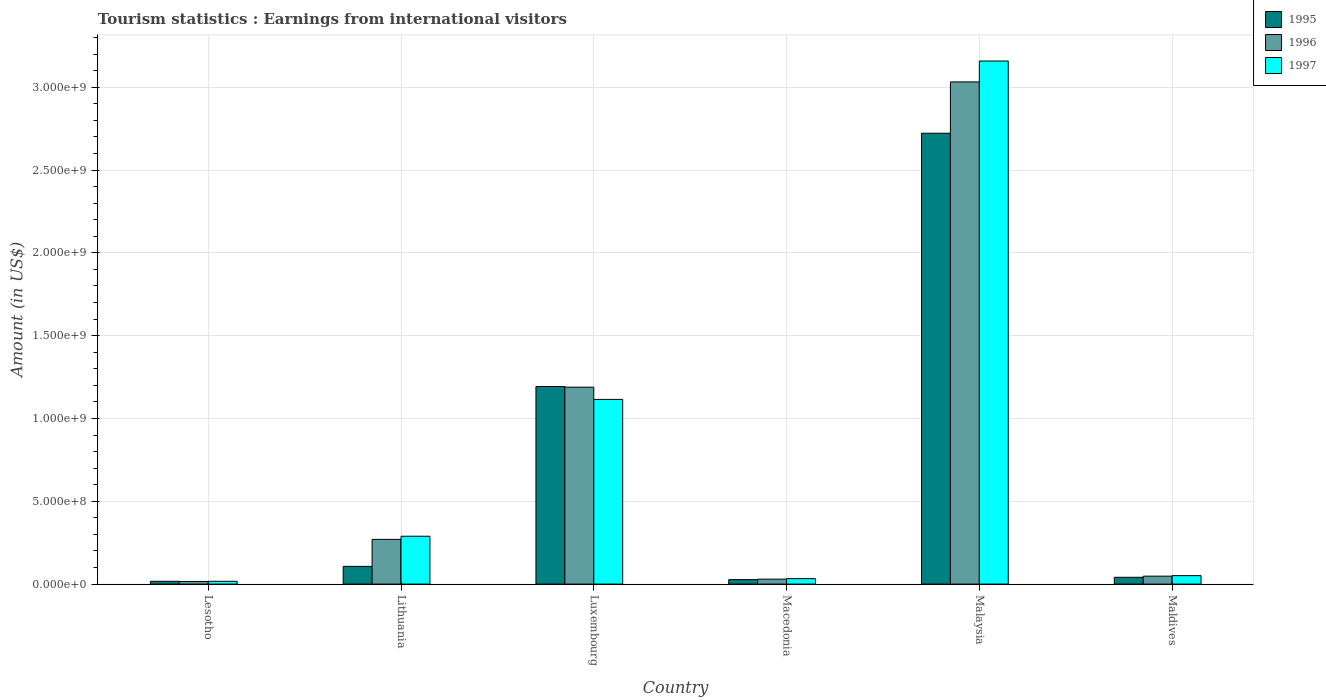How many different coloured bars are there?
Give a very brief answer. 3. Are the number of bars on each tick of the X-axis equal?
Ensure brevity in your answer.  Yes. How many bars are there on the 1st tick from the left?
Offer a terse response. 3. What is the label of the 5th group of bars from the left?
Offer a very short reply. Malaysia. In how many cases, is the number of bars for a given country not equal to the number of legend labels?
Your response must be concise. 0. What is the earnings from international visitors in 1996 in Malaysia?
Offer a terse response. 3.03e+09. Across all countries, what is the maximum earnings from international visitors in 1995?
Offer a terse response. 2.72e+09. Across all countries, what is the minimum earnings from international visitors in 1997?
Offer a very short reply. 1.70e+07. In which country was the earnings from international visitors in 1997 maximum?
Give a very brief answer. Malaysia. In which country was the earnings from international visitors in 1996 minimum?
Offer a terse response. Lesotho. What is the total earnings from international visitors in 1995 in the graph?
Give a very brief answer. 4.11e+09. What is the difference between the earnings from international visitors in 1997 in Lithuania and that in Malaysia?
Ensure brevity in your answer.  -2.87e+09. What is the difference between the earnings from international visitors in 1995 in Malaysia and the earnings from international visitors in 1996 in Luxembourg?
Provide a succinct answer. 1.53e+09. What is the average earnings from international visitors in 1997 per country?
Provide a succinct answer. 7.77e+08. What is the difference between the earnings from international visitors of/in 1995 and earnings from international visitors of/in 1997 in Macedonia?
Keep it short and to the point. -6.00e+06. In how many countries, is the earnings from international visitors in 1997 greater than 2800000000 US$?
Keep it short and to the point. 1. What is the ratio of the earnings from international visitors in 1995 in Lesotho to that in Lithuania?
Keep it short and to the point. 0.16. What is the difference between the highest and the second highest earnings from international visitors in 1995?
Provide a succinct answer. 1.53e+09. What is the difference between the highest and the lowest earnings from international visitors in 1996?
Your answer should be very brief. 3.02e+09. What does the 3rd bar from the right in Lesotho represents?
Provide a succinct answer. 1995. Is it the case that in every country, the sum of the earnings from international visitors in 1995 and earnings from international visitors in 1997 is greater than the earnings from international visitors in 1996?
Give a very brief answer. Yes. How many bars are there?
Offer a very short reply. 18. Are all the bars in the graph horizontal?
Give a very brief answer. No. What is the difference between two consecutive major ticks on the Y-axis?
Give a very brief answer. 5.00e+08. Does the graph contain any zero values?
Offer a terse response. No. Does the graph contain grids?
Make the answer very short. Yes. How many legend labels are there?
Give a very brief answer. 3. How are the legend labels stacked?
Make the answer very short. Vertical. What is the title of the graph?
Your answer should be compact. Tourism statistics : Earnings from international visitors. What is the label or title of the X-axis?
Ensure brevity in your answer.  Country. What is the Amount (in US$) in 1995 in Lesotho?
Ensure brevity in your answer.  1.70e+07. What is the Amount (in US$) of 1996 in Lesotho?
Your answer should be very brief. 1.60e+07. What is the Amount (in US$) of 1997 in Lesotho?
Keep it short and to the point. 1.70e+07. What is the Amount (in US$) in 1995 in Lithuania?
Your answer should be very brief. 1.07e+08. What is the Amount (in US$) of 1996 in Lithuania?
Provide a short and direct response. 2.70e+08. What is the Amount (in US$) of 1997 in Lithuania?
Offer a terse response. 2.89e+08. What is the Amount (in US$) in 1995 in Luxembourg?
Offer a very short reply. 1.19e+09. What is the Amount (in US$) of 1996 in Luxembourg?
Give a very brief answer. 1.19e+09. What is the Amount (in US$) in 1997 in Luxembourg?
Give a very brief answer. 1.12e+09. What is the Amount (in US$) of 1995 in Macedonia?
Provide a short and direct response. 2.70e+07. What is the Amount (in US$) of 1996 in Macedonia?
Provide a succinct answer. 3.00e+07. What is the Amount (in US$) of 1997 in Macedonia?
Offer a terse response. 3.30e+07. What is the Amount (in US$) of 1995 in Malaysia?
Your response must be concise. 2.72e+09. What is the Amount (in US$) of 1996 in Malaysia?
Keep it short and to the point. 3.03e+09. What is the Amount (in US$) in 1997 in Malaysia?
Make the answer very short. 3.16e+09. What is the Amount (in US$) of 1995 in Maldives?
Offer a terse response. 4.10e+07. What is the Amount (in US$) in 1996 in Maldives?
Provide a short and direct response. 4.80e+07. What is the Amount (in US$) in 1997 in Maldives?
Give a very brief answer. 5.10e+07. Across all countries, what is the maximum Amount (in US$) of 1995?
Offer a terse response. 2.72e+09. Across all countries, what is the maximum Amount (in US$) of 1996?
Make the answer very short. 3.03e+09. Across all countries, what is the maximum Amount (in US$) in 1997?
Your response must be concise. 3.16e+09. Across all countries, what is the minimum Amount (in US$) in 1995?
Provide a succinct answer. 1.70e+07. Across all countries, what is the minimum Amount (in US$) in 1996?
Keep it short and to the point. 1.60e+07. Across all countries, what is the minimum Amount (in US$) of 1997?
Make the answer very short. 1.70e+07. What is the total Amount (in US$) in 1995 in the graph?
Ensure brevity in your answer.  4.11e+09. What is the total Amount (in US$) in 1996 in the graph?
Your answer should be compact. 4.58e+09. What is the total Amount (in US$) of 1997 in the graph?
Ensure brevity in your answer.  4.66e+09. What is the difference between the Amount (in US$) of 1995 in Lesotho and that in Lithuania?
Your response must be concise. -9.00e+07. What is the difference between the Amount (in US$) of 1996 in Lesotho and that in Lithuania?
Keep it short and to the point. -2.54e+08. What is the difference between the Amount (in US$) in 1997 in Lesotho and that in Lithuania?
Provide a succinct answer. -2.72e+08. What is the difference between the Amount (in US$) of 1995 in Lesotho and that in Luxembourg?
Your answer should be compact. -1.18e+09. What is the difference between the Amount (in US$) in 1996 in Lesotho and that in Luxembourg?
Your response must be concise. -1.17e+09. What is the difference between the Amount (in US$) of 1997 in Lesotho and that in Luxembourg?
Your answer should be compact. -1.10e+09. What is the difference between the Amount (in US$) of 1995 in Lesotho and that in Macedonia?
Provide a succinct answer. -1.00e+07. What is the difference between the Amount (in US$) of 1996 in Lesotho and that in Macedonia?
Your answer should be very brief. -1.40e+07. What is the difference between the Amount (in US$) in 1997 in Lesotho and that in Macedonia?
Provide a succinct answer. -1.60e+07. What is the difference between the Amount (in US$) of 1995 in Lesotho and that in Malaysia?
Your answer should be very brief. -2.70e+09. What is the difference between the Amount (in US$) of 1996 in Lesotho and that in Malaysia?
Your response must be concise. -3.02e+09. What is the difference between the Amount (in US$) in 1997 in Lesotho and that in Malaysia?
Offer a very short reply. -3.14e+09. What is the difference between the Amount (in US$) in 1995 in Lesotho and that in Maldives?
Your response must be concise. -2.40e+07. What is the difference between the Amount (in US$) of 1996 in Lesotho and that in Maldives?
Offer a very short reply. -3.20e+07. What is the difference between the Amount (in US$) in 1997 in Lesotho and that in Maldives?
Offer a very short reply. -3.40e+07. What is the difference between the Amount (in US$) in 1995 in Lithuania and that in Luxembourg?
Your answer should be very brief. -1.09e+09. What is the difference between the Amount (in US$) in 1996 in Lithuania and that in Luxembourg?
Ensure brevity in your answer.  -9.19e+08. What is the difference between the Amount (in US$) of 1997 in Lithuania and that in Luxembourg?
Give a very brief answer. -8.26e+08. What is the difference between the Amount (in US$) in 1995 in Lithuania and that in Macedonia?
Offer a very short reply. 8.00e+07. What is the difference between the Amount (in US$) in 1996 in Lithuania and that in Macedonia?
Your response must be concise. 2.40e+08. What is the difference between the Amount (in US$) of 1997 in Lithuania and that in Macedonia?
Your answer should be compact. 2.56e+08. What is the difference between the Amount (in US$) of 1995 in Lithuania and that in Malaysia?
Ensure brevity in your answer.  -2.62e+09. What is the difference between the Amount (in US$) of 1996 in Lithuania and that in Malaysia?
Make the answer very short. -2.76e+09. What is the difference between the Amount (in US$) in 1997 in Lithuania and that in Malaysia?
Give a very brief answer. -2.87e+09. What is the difference between the Amount (in US$) in 1995 in Lithuania and that in Maldives?
Provide a short and direct response. 6.60e+07. What is the difference between the Amount (in US$) of 1996 in Lithuania and that in Maldives?
Your answer should be very brief. 2.22e+08. What is the difference between the Amount (in US$) in 1997 in Lithuania and that in Maldives?
Provide a short and direct response. 2.38e+08. What is the difference between the Amount (in US$) in 1995 in Luxembourg and that in Macedonia?
Your answer should be compact. 1.17e+09. What is the difference between the Amount (in US$) in 1996 in Luxembourg and that in Macedonia?
Your response must be concise. 1.16e+09. What is the difference between the Amount (in US$) in 1997 in Luxembourg and that in Macedonia?
Offer a terse response. 1.08e+09. What is the difference between the Amount (in US$) in 1995 in Luxembourg and that in Malaysia?
Your answer should be compact. -1.53e+09. What is the difference between the Amount (in US$) in 1996 in Luxembourg and that in Malaysia?
Keep it short and to the point. -1.84e+09. What is the difference between the Amount (in US$) in 1997 in Luxembourg and that in Malaysia?
Provide a succinct answer. -2.04e+09. What is the difference between the Amount (in US$) of 1995 in Luxembourg and that in Maldives?
Offer a very short reply. 1.15e+09. What is the difference between the Amount (in US$) of 1996 in Luxembourg and that in Maldives?
Make the answer very short. 1.14e+09. What is the difference between the Amount (in US$) in 1997 in Luxembourg and that in Maldives?
Offer a very short reply. 1.06e+09. What is the difference between the Amount (in US$) in 1995 in Macedonia and that in Malaysia?
Keep it short and to the point. -2.70e+09. What is the difference between the Amount (in US$) in 1996 in Macedonia and that in Malaysia?
Keep it short and to the point. -3.00e+09. What is the difference between the Amount (in US$) of 1997 in Macedonia and that in Malaysia?
Your answer should be compact. -3.12e+09. What is the difference between the Amount (in US$) in 1995 in Macedonia and that in Maldives?
Give a very brief answer. -1.40e+07. What is the difference between the Amount (in US$) in 1996 in Macedonia and that in Maldives?
Provide a short and direct response. -1.80e+07. What is the difference between the Amount (in US$) of 1997 in Macedonia and that in Maldives?
Ensure brevity in your answer.  -1.80e+07. What is the difference between the Amount (in US$) in 1995 in Malaysia and that in Maldives?
Your response must be concise. 2.68e+09. What is the difference between the Amount (in US$) in 1996 in Malaysia and that in Maldives?
Ensure brevity in your answer.  2.98e+09. What is the difference between the Amount (in US$) of 1997 in Malaysia and that in Maldives?
Make the answer very short. 3.11e+09. What is the difference between the Amount (in US$) of 1995 in Lesotho and the Amount (in US$) of 1996 in Lithuania?
Provide a succinct answer. -2.53e+08. What is the difference between the Amount (in US$) in 1995 in Lesotho and the Amount (in US$) in 1997 in Lithuania?
Provide a short and direct response. -2.72e+08. What is the difference between the Amount (in US$) of 1996 in Lesotho and the Amount (in US$) of 1997 in Lithuania?
Keep it short and to the point. -2.73e+08. What is the difference between the Amount (in US$) of 1995 in Lesotho and the Amount (in US$) of 1996 in Luxembourg?
Offer a very short reply. -1.17e+09. What is the difference between the Amount (in US$) of 1995 in Lesotho and the Amount (in US$) of 1997 in Luxembourg?
Offer a terse response. -1.10e+09. What is the difference between the Amount (in US$) of 1996 in Lesotho and the Amount (in US$) of 1997 in Luxembourg?
Offer a terse response. -1.10e+09. What is the difference between the Amount (in US$) in 1995 in Lesotho and the Amount (in US$) in 1996 in Macedonia?
Ensure brevity in your answer.  -1.30e+07. What is the difference between the Amount (in US$) in 1995 in Lesotho and the Amount (in US$) in 1997 in Macedonia?
Keep it short and to the point. -1.60e+07. What is the difference between the Amount (in US$) in 1996 in Lesotho and the Amount (in US$) in 1997 in Macedonia?
Offer a terse response. -1.70e+07. What is the difference between the Amount (in US$) in 1995 in Lesotho and the Amount (in US$) in 1996 in Malaysia?
Keep it short and to the point. -3.02e+09. What is the difference between the Amount (in US$) in 1995 in Lesotho and the Amount (in US$) in 1997 in Malaysia?
Provide a succinct answer. -3.14e+09. What is the difference between the Amount (in US$) of 1996 in Lesotho and the Amount (in US$) of 1997 in Malaysia?
Offer a terse response. -3.14e+09. What is the difference between the Amount (in US$) of 1995 in Lesotho and the Amount (in US$) of 1996 in Maldives?
Your response must be concise. -3.10e+07. What is the difference between the Amount (in US$) in 1995 in Lesotho and the Amount (in US$) in 1997 in Maldives?
Your answer should be compact. -3.40e+07. What is the difference between the Amount (in US$) of 1996 in Lesotho and the Amount (in US$) of 1997 in Maldives?
Your response must be concise. -3.50e+07. What is the difference between the Amount (in US$) of 1995 in Lithuania and the Amount (in US$) of 1996 in Luxembourg?
Your answer should be very brief. -1.08e+09. What is the difference between the Amount (in US$) in 1995 in Lithuania and the Amount (in US$) in 1997 in Luxembourg?
Offer a terse response. -1.01e+09. What is the difference between the Amount (in US$) of 1996 in Lithuania and the Amount (in US$) of 1997 in Luxembourg?
Give a very brief answer. -8.45e+08. What is the difference between the Amount (in US$) of 1995 in Lithuania and the Amount (in US$) of 1996 in Macedonia?
Your response must be concise. 7.70e+07. What is the difference between the Amount (in US$) in 1995 in Lithuania and the Amount (in US$) in 1997 in Macedonia?
Provide a short and direct response. 7.40e+07. What is the difference between the Amount (in US$) in 1996 in Lithuania and the Amount (in US$) in 1997 in Macedonia?
Your answer should be compact. 2.37e+08. What is the difference between the Amount (in US$) of 1995 in Lithuania and the Amount (in US$) of 1996 in Malaysia?
Keep it short and to the point. -2.92e+09. What is the difference between the Amount (in US$) in 1995 in Lithuania and the Amount (in US$) in 1997 in Malaysia?
Provide a succinct answer. -3.05e+09. What is the difference between the Amount (in US$) in 1996 in Lithuania and the Amount (in US$) in 1997 in Malaysia?
Offer a very short reply. -2.89e+09. What is the difference between the Amount (in US$) in 1995 in Lithuania and the Amount (in US$) in 1996 in Maldives?
Make the answer very short. 5.90e+07. What is the difference between the Amount (in US$) in 1995 in Lithuania and the Amount (in US$) in 1997 in Maldives?
Offer a terse response. 5.60e+07. What is the difference between the Amount (in US$) of 1996 in Lithuania and the Amount (in US$) of 1997 in Maldives?
Provide a short and direct response. 2.19e+08. What is the difference between the Amount (in US$) of 1995 in Luxembourg and the Amount (in US$) of 1996 in Macedonia?
Your answer should be compact. 1.16e+09. What is the difference between the Amount (in US$) in 1995 in Luxembourg and the Amount (in US$) in 1997 in Macedonia?
Keep it short and to the point. 1.16e+09. What is the difference between the Amount (in US$) in 1996 in Luxembourg and the Amount (in US$) in 1997 in Macedonia?
Your answer should be very brief. 1.16e+09. What is the difference between the Amount (in US$) of 1995 in Luxembourg and the Amount (in US$) of 1996 in Malaysia?
Ensure brevity in your answer.  -1.84e+09. What is the difference between the Amount (in US$) in 1995 in Luxembourg and the Amount (in US$) in 1997 in Malaysia?
Provide a succinct answer. -1.96e+09. What is the difference between the Amount (in US$) in 1996 in Luxembourg and the Amount (in US$) in 1997 in Malaysia?
Your response must be concise. -1.97e+09. What is the difference between the Amount (in US$) in 1995 in Luxembourg and the Amount (in US$) in 1996 in Maldives?
Give a very brief answer. 1.14e+09. What is the difference between the Amount (in US$) of 1995 in Luxembourg and the Amount (in US$) of 1997 in Maldives?
Offer a terse response. 1.14e+09. What is the difference between the Amount (in US$) of 1996 in Luxembourg and the Amount (in US$) of 1997 in Maldives?
Keep it short and to the point. 1.14e+09. What is the difference between the Amount (in US$) of 1995 in Macedonia and the Amount (in US$) of 1996 in Malaysia?
Provide a short and direct response. -3.00e+09. What is the difference between the Amount (in US$) of 1995 in Macedonia and the Amount (in US$) of 1997 in Malaysia?
Give a very brief answer. -3.13e+09. What is the difference between the Amount (in US$) of 1996 in Macedonia and the Amount (in US$) of 1997 in Malaysia?
Offer a very short reply. -3.13e+09. What is the difference between the Amount (in US$) of 1995 in Macedonia and the Amount (in US$) of 1996 in Maldives?
Provide a short and direct response. -2.10e+07. What is the difference between the Amount (in US$) of 1995 in Macedonia and the Amount (in US$) of 1997 in Maldives?
Your answer should be compact. -2.40e+07. What is the difference between the Amount (in US$) of 1996 in Macedonia and the Amount (in US$) of 1997 in Maldives?
Your response must be concise. -2.10e+07. What is the difference between the Amount (in US$) in 1995 in Malaysia and the Amount (in US$) in 1996 in Maldives?
Offer a very short reply. 2.67e+09. What is the difference between the Amount (in US$) in 1995 in Malaysia and the Amount (in US$) in 1997 in Maldives?
Ensure brevity in your answer.  2.67e+09. What is the difference between the Amount (in US$) of 1996 in Malaysia and the Amount (in US$) of 1997 in Maldives?
Keep it short and to the point. 2.98e+09. What is the average Amount (in US$) in 1995 per country?
Make the answer very short. 6.84e+08. What is the average Amount (in US$) of 1996 per country?
Give a very brief answer. 7.64e+08. What is the average Amount (in US$) in 1997 per country?
Your response must be concise. 7.77e+08. What is the difference between the Amount (in US$) in 1995 and Amount (in US$) in 1996 in Lesotho?
Offer a very short reply. 1.00e+06. What is the difference between the Amount (in US$) of 1995 and Amount (in US$) of 1997 in Lesotho?
Make the answer very short. 0. What is the difference between the Amount (in US$) in 1996 and Amount (in US$) in 1997 in Lesotho?
Give a very brief answer. -1.00e+06. What is the difference between the Amount (in US$) of 1995 and Amount (in US$) of 1996 in Lithuania?
Provide a short and direct response. -1.63e+08. What is the difference between the Amount (in US$) of 1995 and Amount (in US$) of 1997 in Lithuania?
Provide a short and direct response. -1.82e+08. What is the difference between the Amount (in US$) of 1996 and Amount (in US$) of 1997 in Lithuania?
Make the answer very short. -1.90e+07. What is the difference between the Amount (in US$) in 1995 and Amount (in US$) in 1996 in Luxembourg?
Your answer should be very brief. 4.00e+06. What is the difference between the Amount (in US$) in 1995 and Amount (in US$) in 1997 in Luxembourg?
Provide a short and direct response. 7.80e+07. What is the difference between the Amount (in US$) of 1996 and Amount (in US$) of 1997 in Luxembourg?
Your response must be concise. 7.40e+07. What is the difference between the Amount (in US$) in 1995 and Amount (in US$) in 1996 in Macedonia?
Make the answer very short. -3.00e+06. What is the difference between the Amount (in US$) in 1995 and Amount (in US$) in 1997 in Macedonia?
Provide a succinct answer. -6.00e+06. What is the difference between the Amount (in US$) in 1995 and Amount (in US$) in 1996 in Malaysia?
Give a very brief answer. -3.10e+08. What is the difference between the Amount (in US$) in 1995 and Amount (in US$) in 1997 in Malaysia?
Your answer should be very brief. -4.36e+08. What is the difference between the Amount (in US$) of 1996 and Amount (in US$) of 1997 in Malaysia?
Your answer should be very brief. -1.26e+08. What is the difference between the Amount (in US$) in 1995 and Amount (in US$) in 1996 in Maldives?
Ensure brevity in your answer.  -7.00e+06. What is the difference between the Amount (in US$) of 1995 and Amount (in US$) of 1997 in Maldives?
Your answer should be compact. -1.00e+07. What is the ratio of the Amount (in US$) of 1995 in Lesotho to that in Lithuania?
Ensure brevity in your answer.  0.16. What is the ratio of the Amount (in US$) of 1996 in Lesotho to that in Lithuania?
Provide a succinct answer. 0.06. What is the ratio of the Amount (in US$) in 1997 in Lesotho to that in Lithuania?
Your answer should be compact. 0.06. What is the ratio of the Amount (in US$) in 1995 in Lesotho to that in Luxembourg?
Your response must be concise. 0.01. What is the ratio of the Amount (in US$) in 1996 in Lesotho to that in Luxembourg?
Your response must be concise. 0.01. What is the ratio of the Amount (in US$) in 1997 in Lesotho to that in Luxembourg?
Your answer should be compact. 0.02. What is the ratio of the Amount (in US$) of 1995 in Lesotho to that in Macedonia?
Provide a short and direct response. 0.63. What is the ratio of the Amount (in US$) in 1996 in Lesotho to that in Macedonia?
Provide a succinct answer. 0.53. What is the ratio of the Amount (in US$) in 1997 in Lesotho to that in Macedonia?
Provide a succinct answer. 0.52. What is the ratio of the Amount (in US$) of 1995 in Lesotho to that in Malaysia?
Your answer should be compact. 0.01. What is the ratio of the Amount (in US$) in 1996 in Lesotho to that in Malaysia?
Offer a very short reply. 0.01. What is the ratio of the Amount (in US$) of 1997 in Lesotho to that in Malaysia?
Provide a short and direct response. 0.01. What is the ratio of the Amount (in US$) in 1995 in Lesotho to that in Maldives?
Offer a very short reply. 0.41. What is the ratio of the Amount (in US$) in 1996 in Lesotho to that in Maldives?
Keep it short and to the point. 0.33. What is the ratio of the Amount (in US$) in 1995 in Lithuania to that in Luxembourg?
Ensure brevity in your answer.  0.09. What is the ratio of the Amount (in US$) in 1996 in Lithuania to that in Luxembourg?
Your answer should be very brief. 0.23. What is the ratio of the Amount (in US$) in 1997 in Lithuania to that in Luxembourg?
Offer a terse response. 0.26. What is the ratio of the Amount (in US$) of 1995 in Lithuania to that in Macedonia?
Provide a succinct answer. 3.96. What is the ratio of the Amount (in US$) of 1996 in Lithuania to that in Macedonia?
Provide a short and direct response. 9. What is the ratio of the Amount (in US$) of 1997 in Lithuania to that in Macedonia?
Provide a succinct answer. 8.76. What is the ratio of the Amount (in US$) in 1995 in Lithuania to that in Malaysia?
Provide a succinct answer. 0.04. What is the ratio of the Amount (in US$) of 1996 in Lithuania to that in Malaysia?
Make the answer very short. 0.09. What is the ratio of the Amount (in US$) of 1997 in Lithuania to that in Malaysia?
Your answer should be very brief. 0.09. What is the ratio of the Amount (in US$) in 1995 in Lithuania to that in Maldives?
Make the answer very short. 2.61. What is the ratio of the Amount (in US$) in 1996 in Lithuania to that in Maldives?
Your response must be concise. 5.62. What is the ratio of the Amount (in US$) in 1997 in Lithuania to that in Maldives?
Give a very brief answer. 5.67. What is the ratio of the Amount (in US$) of 1995 in Luxembourg to that in Macedonia?
Provide a succinct answer. 44.19. What is the ratio of the Amount (in US$) of 1996 in Luxembourg to that in Macedonia?
Your response must be concise. 39.63. What is the ratio of the Amount (in US$) in 1997 in Luxembourg to that in Macedonia?
Offer a very short reply. 33.79. What is the ratio of the Amount (in US$) in 1995 in Luxembourg to that in Malaysia?
Provide a short and direct response. 0.44. What is the ratio of the Amount (in US$) in 1996 in Luxembourg to that in Malaysia?
Keep it short and to the point. 0.39. What is the ratio of the Amount (in US$) in 1997 in Luxembourg to that in Malaysia?
Keep it short and to the point. 0.35. What is the ratio of the Amount (in US$) in 1995 in Luxembourg to that in Maldives?
Your response must be concise. 29.1. What is the ratio of the Amount (in US$) in 1996 in Luxembourg to that in Maldives?
Make the answer very short. 24.77. What is the ratio of the Amount (in US$) in 1997 in Luxembourg to that in Maldives?
Keep it short and to the point. 21.86. What is the ratio of the Amount (in US$) of 1995 in Macedonia to that in Malaysia?
Make the answer very short. 0.01. What is the ratio of the Amount (in US$) in 1996 in Macedonia to that in Malaysia?
Ensure brevity in your answer.  0.01. What is the ratio of the Amount (in US$) in 1997 in Macedonia to that in Malaysia?
Provide a succinct answer. 0.01. What is the ratio of the Amount (in US$) of 1995 in Macedonia to that in Maldives?
Ensure brevity in your answer.  0.66. What is the ratio of the Amount (in US$) of 1996 in Macedonia to that in Maldives?
Offer a terse response. 0.62. What is the ratio of the Amount (in US$) in 1997 in Macedonia to that in Maldives?
Keep it short and to the point. 0.65. What is the ratio of the Amount (in US$) in 1995 in Malaysia to that in Maldives?
Provide a short and direct response. 66.39. What is the ratio of the Amount (in US$) of 1996 in Malaysia to that in Maldives?
Ensure brevity in your answer.  63.17. What is the ratio of the Amount (in US$) of 1997 in Malaysia to that in Maldives?
Make the answer very short. 61.92. What is the difference between the highest and the second highest Amount (in US$) of 1995?
Your answer should be very brief. 1.53e+09. What is the difference between the highest and the second highest Amount (in US$) of 1996?
Provide a short and direct response. 1.84e+09. What is the difference between the highest and the second highest Amount (in US$) in 1997?
Offer a terse response. 2.04e+09. What is the difference between the highest and the lowest Amount (in US$) in 1995?
Provide a succinct answer. 2.70e+09. What is the difference between the highest and the lowest Amount (in US$) of 1996?
Offer a terse response. 3.02e+09. What is the difference between the highest and the lowest Amount (in US$) of 1997?
Offer a very short reply. 3.14e+09. 